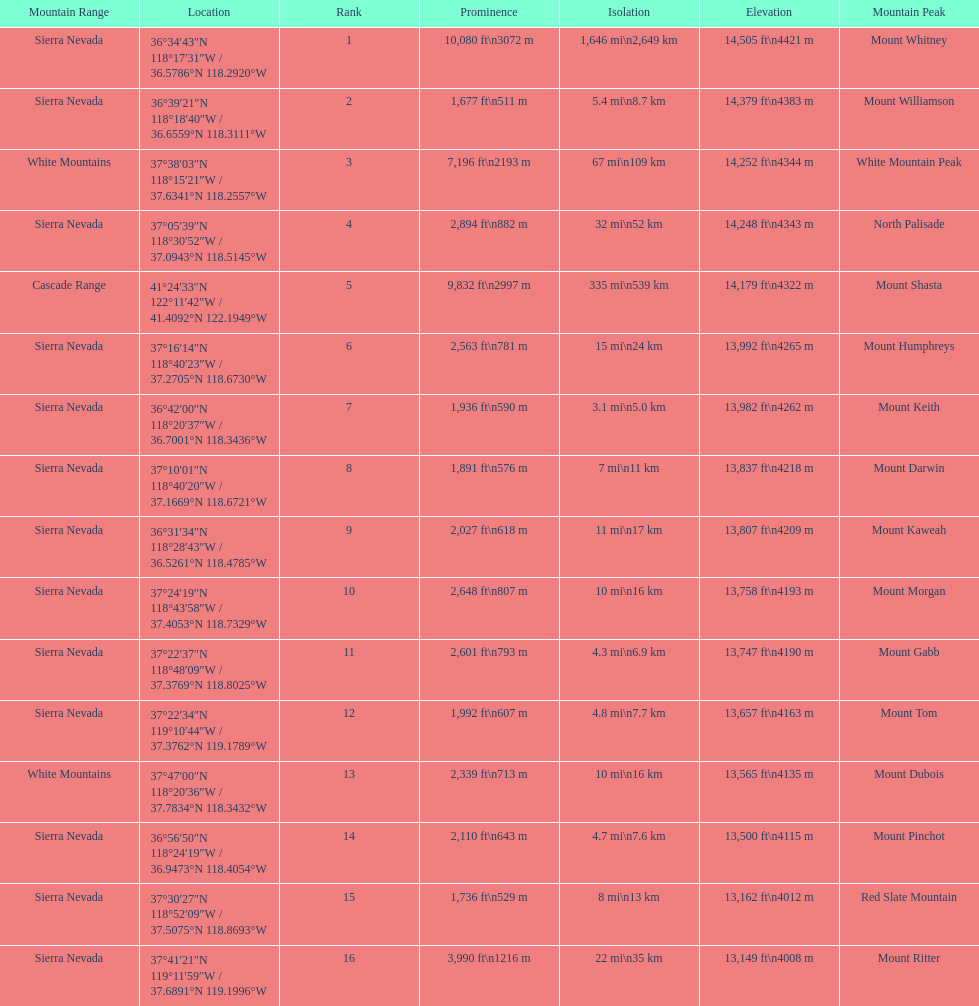What are the listed elevations? 14,505 ft\n4421 m, 14,379 ft\n4383 m, 14,252 ft\n4344 m, 14,248 ft\n4343 m, 14,179 ft\n4322 m, 13,992 ft\n4265 m, 13,982 ft\n4262 m, 13,837 ft\n4218 m, 13,807 ft\n4209 m, 13,758 ft\n4193 m, 13,747 ft\n4190 m, 13,657 ft\n4163 m, 13,565 ft\n4135 m, 13,500 ft\n4115 m, 13,162 ft\n4012 m, 13,149 ft\n4008 m. Which of those is 13,149 ft or below? 13,149 ft\n4008 m. To what mountain peak does that value correspond? Mount Ritter. 